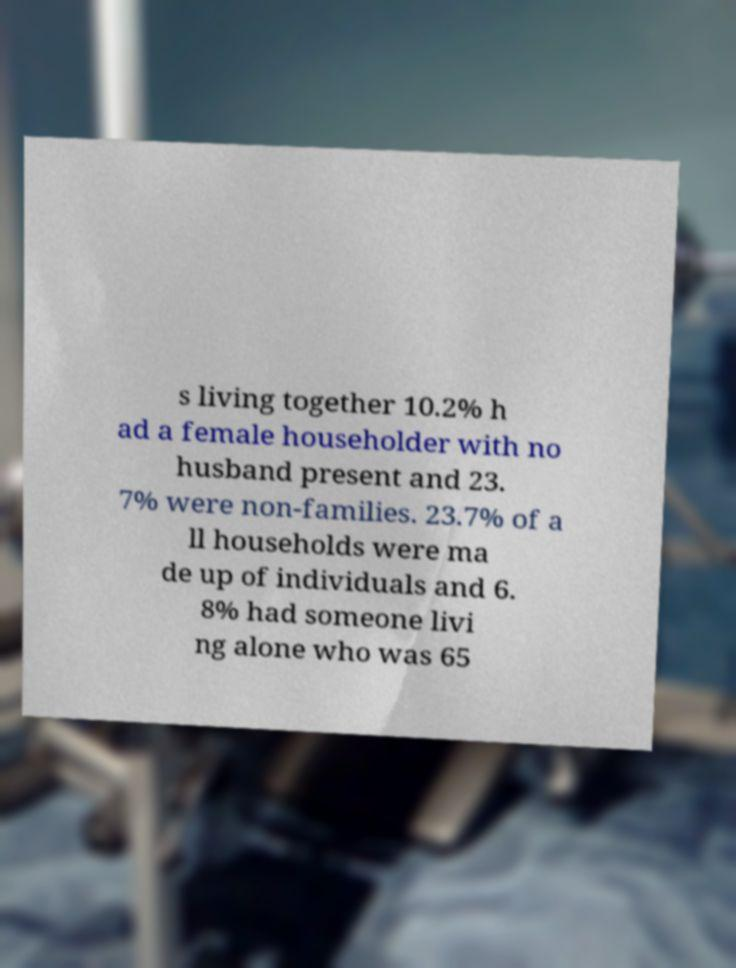What messages or text are displayed in this image? I need them in a readable, typed format. s living together 10.2% h ad a female householder with no husband present and 23. 7% were non-families. 23.7% of a ll households were ma de up of individuals and 6. 8% had someone livi ng alone who was 65 